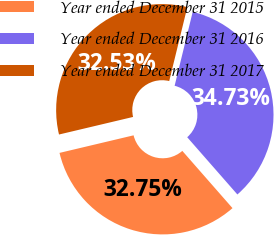Convert chart to OTSL. <chart><loc_0><loc_0><loc_500><loc_500><pie_chart><fcel>Year ended December 31 2015<fcel>Year ended December 31 2016<fcel>Year ended December 31 2017<nl><fcel>32.75%<fcel>34.73%<fcel>32.53%<nl></chart> 